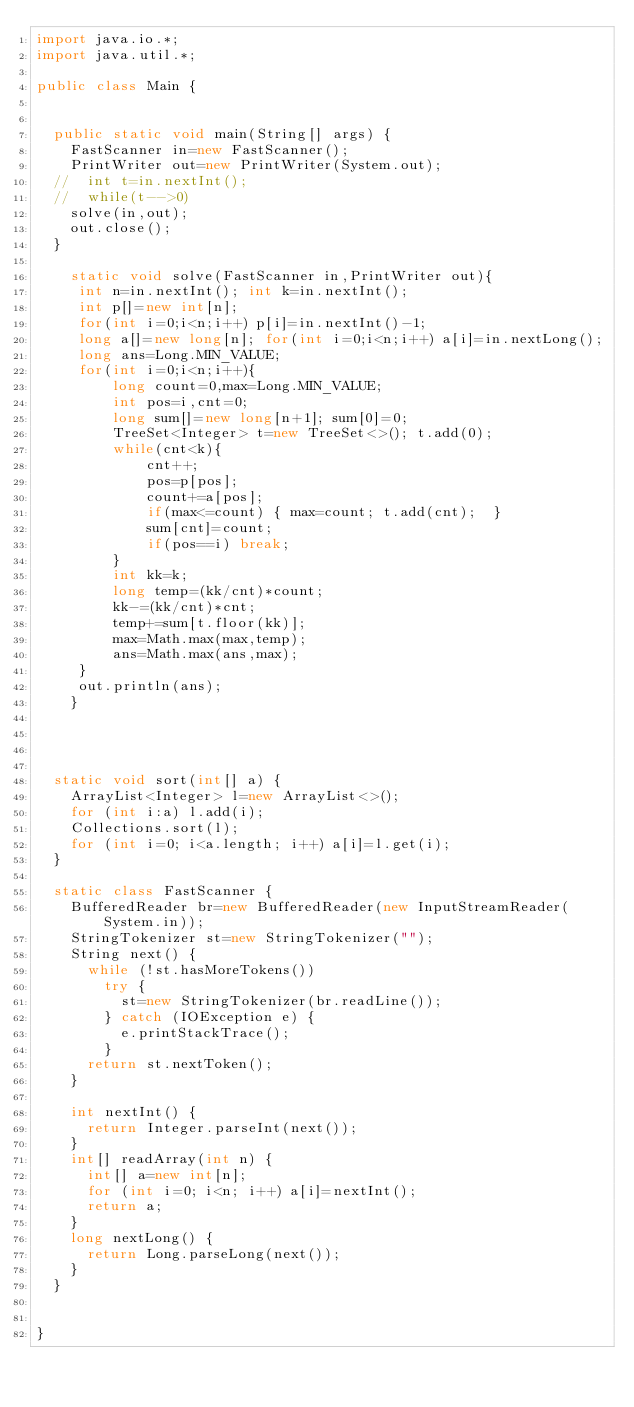<code> <loc_0><loc_0><loc_500><loc_500><_Java_>import java.io.*;
import java.util.*;

public class Main {

	
	public static void main(String[] args) {
		FastScanner in=new FastScanner();
		PrintWriter out=new PrintWriter(System.out);
	//	int t=in.nextInt();
	//	while(t-->0)
		solve(in,out);
		out.close();
	}

    static void solve(FastScanner in,PrintWriter out){
     int n=in.nextInt(); int k=in.nextInt();
     int p[]=new int[n];
     for(int i=0;i<n;i++) p[i]=in.nextInt()-1;
     long a[]=new long[n]; for(int i=0;i<n;i++) a[i]=in.nextLong();
     long ans=Long.MIN_VALUE;
     for(int i=0;i<n;i++){
         long count=0,max=Long.MIN_VALUE;
         int pos=i,cnt=0;
         long sum[]=new long[n+1]; sum[0]=0;
         TreeSet<Integer> t=new TreeSet<>(); t.add(0);
         while(cnt<k){
             cnt++;
             pos=p[pos];
             count+=a[pos];
             if(max<=count) { max=count; t.add(cnt);  }
             sum[cnt]=count;
             if(pos==i) break;
         }
         int kk=k;
         long temp=(kk/cnt)*count;
         kk-=(kk/cnt)*cnt;
         temp+=sum[t.floor(kk)];
         max=Math.max(max,temp);
         ans=Math.max(ans,max);
     }
     out.println(ans);
    }    
	



	static void sort(int[] a) {
		ArrayList<Integer> l=new ArrayList<>();
		for (int i:a) l.add(i);
		Collections.sort(l);
		for (int i=0; i<a.length; i++) a[i]=l.get(i);
	}
	
	static class FastScanner {
		BufferedReader br=new BufferedReader(new InputStreamReader(System.in));
		StringTokenizer st=new StringTokenizer("");
		String next() {
			while (!st.hasMoreTokens())
				try {
					st=new StringTokenizer(br.readLine());
				} catch (IOException e) {
					e.printStackTrace();
				}
			return st.nextToken();
		}
		
		int nextInt() {
			return Integer.parseInt(next());
		}
		int[] readArray(int n) {
			int[] a=new int[n];
			for (int i=0; i<n; i++) a[i]=nextInt();
			return a;
		}
		long nextLong() {
			return Long.parseLong(next());
		}
	}

	
}
</code> 